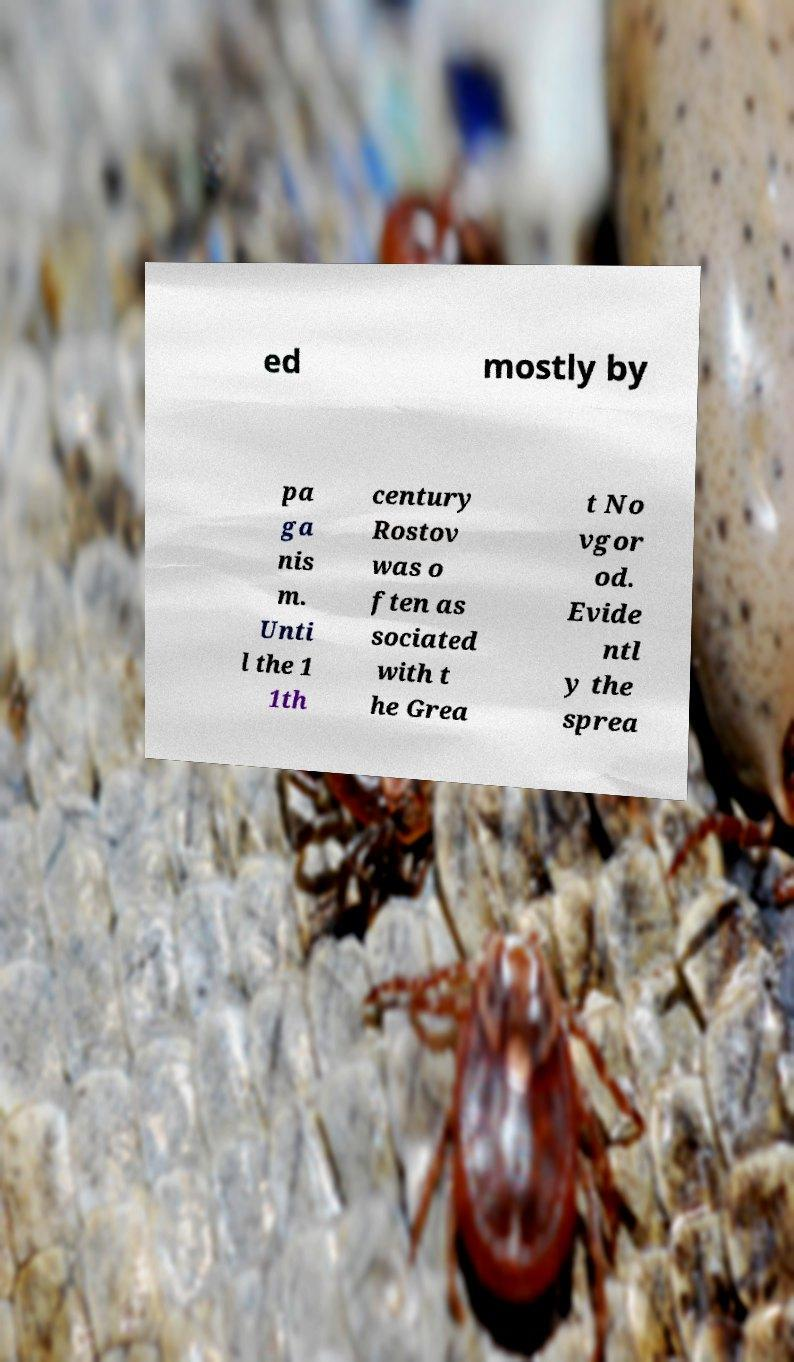Can you accurately transcribe the text from the provided image for me? ed mostly by pa ga nis m. Unti l the 1 1th century Rostov was o ften as sociated with t he Grea t No vgor od. Evide ntl y the sprea 